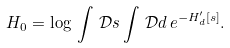Convert formula to latex. <formula><loc_0><loc_0><loc_500><loc_500>H _ { 0 } = \log \, \int \, \mathcal { D } s \int \, \mathcal { D } d \, e ^ { - H _ { d } ^ { \prime } [ s ] } .</formula> 